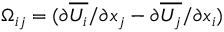<formula> <loc_0><loc_0><loc_500><loc_500>\Omega _ { i j } = ( { \partial \overline { { U _ { i } } } / \partial x _ { j } } - { \partial \overline { { U _ { j } } } / \partial x _ { i } } )</formula> 